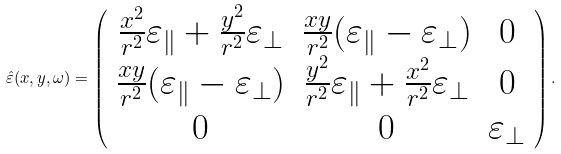<formula> <loc_0><loc_0><loc_500><loc_500>\hat { \varepsilon } ( x , y , \omega ) = \left ( \begin{array} { c c c } \frac { x ^ { 2 } } { r ^ { 2 } } \varepsilon _ { \| } + \frac { y ^ { 2 } } { r ^ { 2 } } \varepsilon _ { \perp } & \frac { x y } { r ^ { 2 } } ( \varepsilon _ { \| } - \varepsilon _ { \perp } ) & 0 \\ \frac { x y } { r ^ { 2 } } ( \varepsilon _ { \| } - \varepsilon _ { \perp } ) & \frac { y ^ { 2 } } { r ^ { 2 } } \varepsilon _ { \| } + \frac { x ^ { 2 } } { r ^ { 2 } } \varepsilon _ { \perp } & 0 \\ 0 & 0 & \varepsilon _ { \perp } \end{array} \right ) .</formula> 